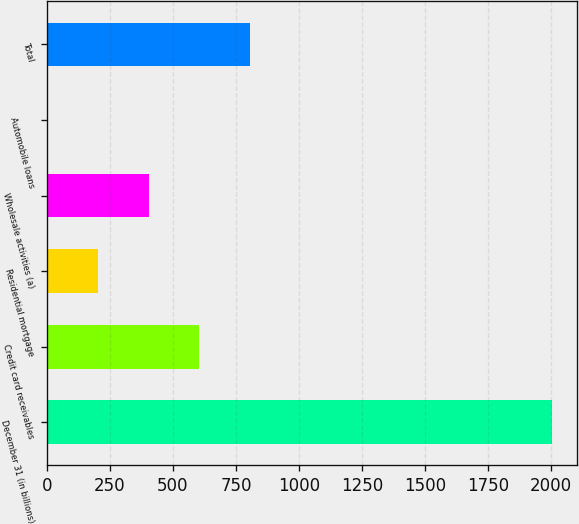Convert chart to OTSL. <chart><loc_0><loc_0><loc_500><loc_500><bar_chart><fcel>December 31 (in billions)<fcel>Credit card receivables<fcel>Residential mortgage<fcel>Wholesale activities (a)<fcel>Automobile loans<fcel>Total<nl><fcel>2004<fcel>604.63<fcel>204.81<fcel>404.72<fcel>4.9<fcel>804.54<nl></chart> 